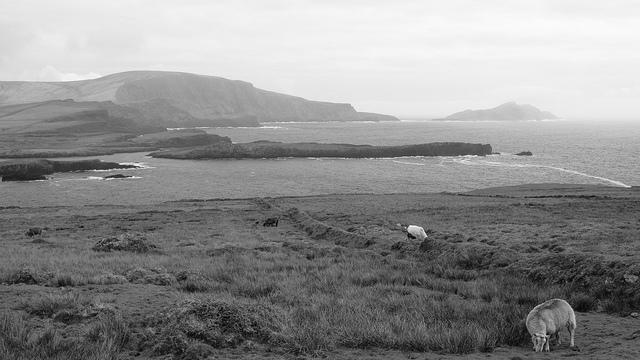What kind of an area is this? coastal 